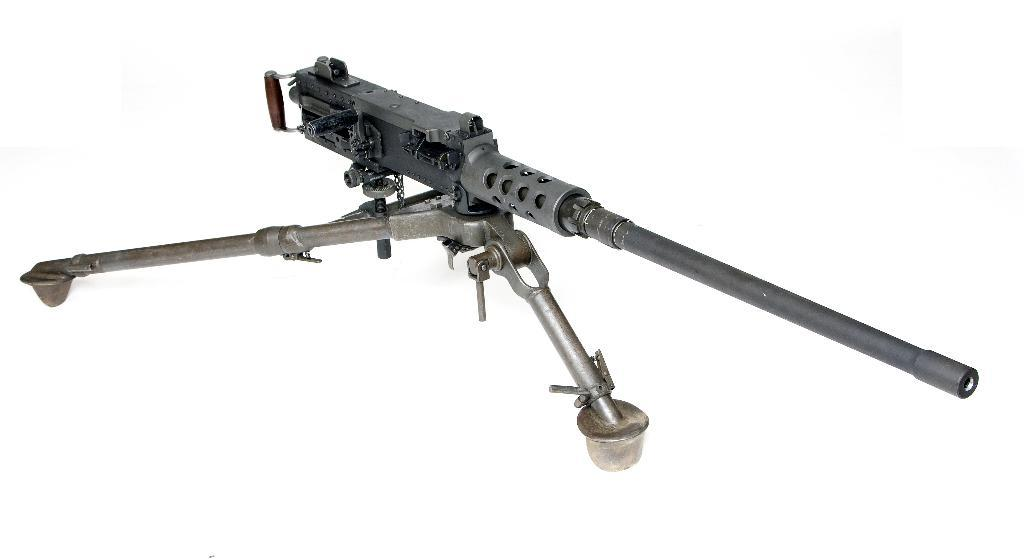What object is the main focus of the image? There is a gun in the image. What color is the background of the image? The background of the image is white. What type of hospital is depicted in the image? There is no hospital present in the image; it features a gun and a white background. What kind of business is being conducted in the image? There is no business activity depicted in the image; it features a gun and a white background. 